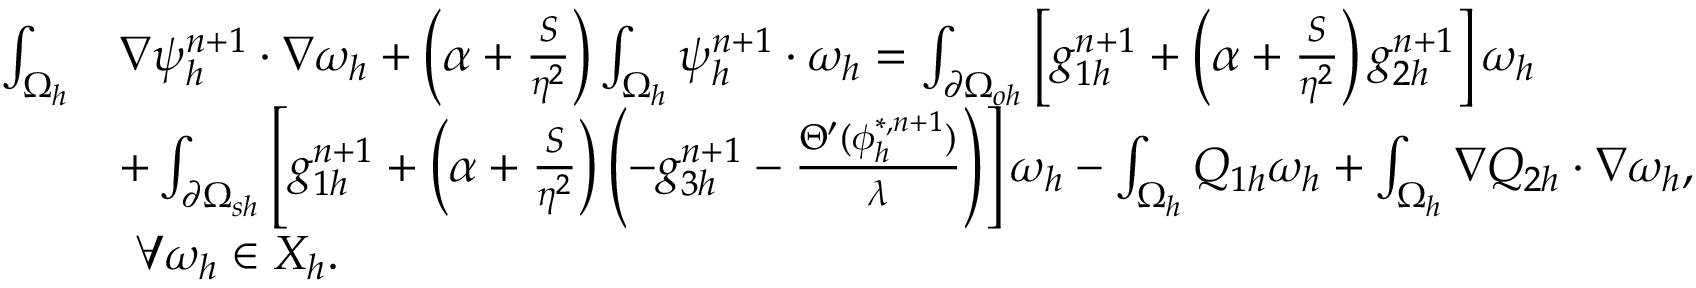<formula> <loc_0><loc_0><loc_500><loc_500>\begin{array} { r l } { \int _ { \Omega _ { h } } } & { \nabla \psi _ { h } ^ { n + 1 } \cdot \nabla \omega _ { h } + \left ( \alpha + \frac { S } { \eta ^ { 2 } } \right ) \int _ { \Omega _ { h } } \psi _ { h } ^ { n + 1 } \cdot \omega _ { h } = \int _ { \partial \Omega _ { o h } } \left [ g _ { 1 h } ^ { n + 1 } + \left ( \alpha + \frac { S } { \eta ^ { 2 } } \right ) g _ { 2 h } ^ { n + 1 } \right ] \omega _ { h } } \\ & { + \int _ { \partial \Omega _ { s h } } \left [ g _ { 1 h } ^ { n + 1 } + \left ( \alpha + \frac { S } { \eta ^ { 2 } } \right ) \left ( - g _ { 3 h } ^ { n + 1 } - \frac { \Theta ^ { \prime } ( \phi _ { h } ^ { * , n + 1 } ) } { \lambda } \right ) \right ] \omega _ { h } - \int _ { \Omega _ { h } } Q _ { 1 h } \omega _ { h } + \int _ { \Omega _ { h } } \nabla Q _ { 2 h } \cdot \nabla \omega _ { h } , } \\ & { \ \forall \omega _ { h } \in X _ { h } . } \end{array}</formula> 